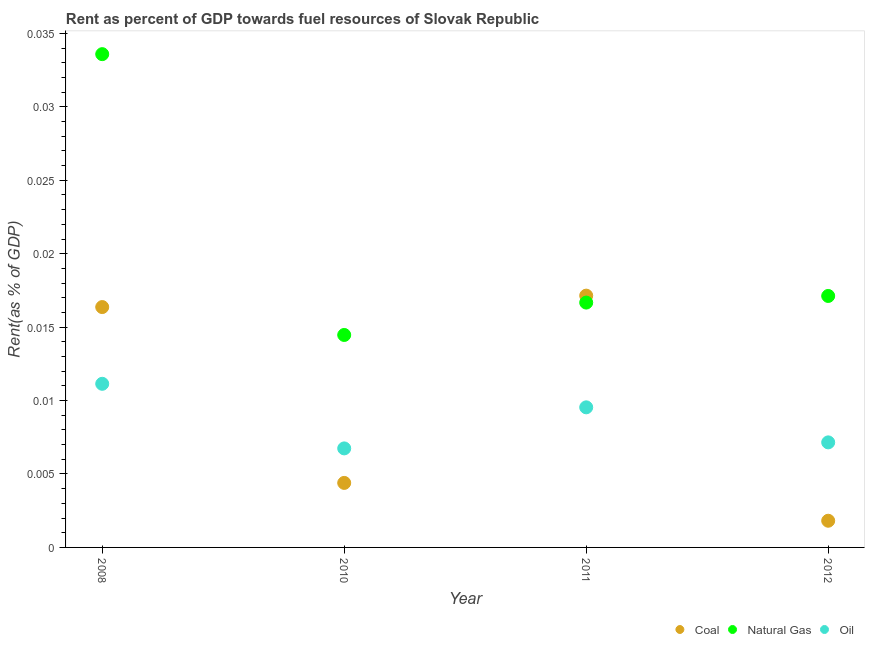How many different coloured dotlines are there?
Offer a very short reply. 3. What is the rent towards natural gas in 2012?
Your response must be concise. 0.02. Across all years, what is the maximum rent towards coal?
Give a very brief answer. 0.02. Across all years, what is the minimum rent towards oil?
Your answer should be compact. 0.01. In which year was the rent towards oil minimum?
Provide a succinct answer. 2010. What is the total rent towards oil in the graph?
Make the answer very short. 0.03. What is the difference between the rent towards coal in 2008 and that in 2010?
Give a very brief answer. 0.01. What is the difference between the rent towards oil in 2011 and the rent towards natural gas in 2010?
Give a very brief answer. -0. What is the average rent towards oil per year?
Make the answer very short. 0.01. In the year 2012, what is the difference between the rent towards coal and rent towards natural gas?
Give a very brief answer. -0.02. In how many years, is the rent towards oil greater than 0.007 %?
Make the answer very short. 3. What is the ratio of the rent towards coal in 2008 to that in 2012?
Offer a very short reply. 9.01. Is the rent towards coal in 2008 less than that in 2010?
Provide a succinct answer. No. What is the difference between the highest and the second highest rent towards coal?
Keep it short and to the point. 0. What is the difference between the highest and the lowest rent towards oil?
Provide a short and direct response. 0. In how many years, is the rent towards coal greater than the average rent towards coal taken over all years?
Your response must be concise. 2. Is the sum of the rent towards oil in 2008 and 2010 greater than the maximum rent towards coal across all years?
Provide a succinct answer. Yes. Is it the case that in every year, the sum of the rent towards coal and rent towards natural gas is greater than the rent towards oil?
Your response must be concise. Yes. Does the rent towards coal monotonically increase over the years?
Ensure brevity in your answer.  No. Is the rent towards natural gas strictly less than the rent towards coal over the years?
Your answer should be very brief. No. How many dotlines are there?
Your answer should be very brief. 3. How many years are there in the graph?
Provide a short and direct response. 4. What is the difference between two consecutive major ticks on the Y-axis?
Your answer should be compact. 0.01. Are the values on the major ticks of Y-axis written in scientific E-notation?
Your response must be concise. No. How are the legend labels stacked?
Your answer should be compact. Horizontal. What is the title of the graph?
Your answer should be very brief. Rent as percent of GDP towards fuel resources of Slovak Republic. What is the label or title of the Y-axis?
Make the answer very short. Rent(as % of GDP). What is the Rent(as % of GDP) in Coal in 2008?
Keep it short and to the point. 0.02. What is the Rent(as % of GDP) in Natural Gas in 2008?
Provide a succinct answer. 0.03. What is the Rent(as % of GDP) in Oil in 2008?
Make the answer very short. 0.01. What is the Rent(as % of GDP) in Coal in 2010?
Offer a terse response. 0. What is the Rent(as % of GDP) in Natural Gas in 2010?
Provide a succinct answer. 0.01. What is the Rent(as % of GDP) of Oil in 2010?
Provide a short and direct response. 0.01. What is the Rent(as % of GDP) of Coal in 2011?
Provide a short and direct response. 0.02. What is the Rent(as % of GDP) of Natural Gas in 2011?
Your response must be concise. 0.02. What is the Rent(as % of GDP) in Oil in 2011?
Your response must be concise. 0.01. What is the Rent(as % of GDP) in Coal in 2012?
Your answer should be very brief. 0. What is the Rent(as % of GDP) of Natural Gas in 2012?
Provide a succinct answer. 0.02. What is the Rent(as % of GDP) in Oil in 2012?
Ensure brevity in your answer.  0.01. Across all years, what is the maximum Rent(as % of GDP) in Coal?
Keep it short and to the point. 0.02. Across all years, what is the maximum Rent(as % of GDP) of Natural Gas?
Provide a short and direct response. 0.03. Across all years, what is the maximum Rent(as % of GDP) in Oil?
Give a very brief answer. 0.01. Across all years, what is the minimum Rent(as % of GDP) in Coal?
Your answer should be very brief. 0. Across all years, what is the minimum Rent(as % of GDP) in Natural Gas?
Keep it short and to the point. 0.01. Across all years, what is the minimum Rent(as % of GDP) of Oil?
Offer a terse response. 0.01. What is the total Rent(as % of GDP) in Coal in the graph?
Provide a succinct answer. 0.04. What is the total Rent(as % of GDP) in Natural Gas in the graph?
Keep it short and to the point. 0.08. What is the total Rent(as % of GDP) of Oil in the graph?
Keep it short and to the point. 0.03. What is the difference between the Rent(as % of GDP) of Coal in 2008 and that in 2010?
Offer a very short reply. 0.01. What is the difference between the Rent(as % of GDP) in Natural Gas in 2008 and that in 2010?
Provide a succinct answer. 0.02. What is the difference between the Rent(as % of GDP) of Oil in 2008 and that in 2010?
Provide a succinct answer. 0. What is the difference between the Rent(as % of GDP) in Coal in 2008 and that in 2011?
Your response must be concise. -0. What is the difference between the Rent(as % of GDP) in Natural Gas in 2008 and that in 2011?
Offer a terse response. 0.02. What is the difference between the Rent(as % of GDP) of Oil in 2008 and that in 2011?
Provide a short and direct response. 0. What is the difference between the Rent(as % of GDP) of Coal in 2008 and that in 2012?
Provide a short and direct response. 0.01. What is the difference between the Rent(as % of GDP) of Natural Gas in 2008 and that in 2012?
Keep it short and to the point. 0.02. What is the difference between the Rent(as % of GDP) in Oil in 2008 and that in 2012?
Your response must be concise. 0. What is the difference between the Rent(as % of GDP) in Coal in 2010 and that in 2011?
Offer a terse response. -0.01. What is the difference between the Rent(as % of GDP) in Natural Gas in 2010 and that in 2011?
Offer a very short reply. -0. What is the difference between the Rent(as % of GDP) in Oil in 2010 and that in 2011?
Provide a succinct answer. -0. What is the difference between the Rent(as % of GDP) of Coal in 2010 and that in 2012?
Provide a short and direct response. 0. What is the difference between the Rent(as % of GDP) in Natural Gas in 2010 and that in 2012?
Your answer should be compact. -0. What is the difference between the Rent(as % of GDP) in Oil in 2010 and that in 2012?
Offer a terse response. -0. What is the difference between the Rent(as % of GDP) of Coal in 2011 and that in 2012?
Your answer should be compact. 0.02. What is the difference between the Rent(as % of GDP) in Natural Gas in 2011 and that in 2012?
Provide a succinct answer. -0. What is the difference between the Rent(as % of GDP) of Oil in 2011 and that in 2012?
Give a very brief answer. 0. What is the difference between the Rent(as % of GDP) in Coal in 2008 and the Rent(as % of GDP) in Natural Gas in 2010?
Provide a succinct answer. 0. What is the difference between the Rent(as % of GDP) in Coal in 2008 and the Rent(as % of GDP) in Oil in 2010?
Give a very brief answer. 0.01. What is the difference between the Rent(as % of GDP) of Natural Gas in 2008 and the Rent(as % of GDP) of Oil in 2010?
Your response must be concise. 0.03. What is the difference between the Rent(as % of GDP) of Coal in 2008 and the Rent(as % of GDP) of Natural Gas in 2011?
Your response must be concise. -0. What is the difference between the Rent(as % of GDP) of Coal in 2008 and the Rent(as % of GDP) of Oil in 2011?
Keep it short and to the point. 0.01. What is the difference between the Rent(as % of GDP) in Natural Gas in 2008 and the Rent(as % of GDP) in Oil in 2011?
Your response must be concise. 0.02. What is the difference between the Rent(as % of GDP) in Coal in 2008 and the Rent(as % of GDP) in Natural Gas in 2012?
Keep it short and to the point. -0. What is the difference between the Rent(as % of GDP) of Coal in 2008 and the Rent(as % of GDP) of Oil in 2012?
Provide a succinct answer. 0.01. What is the difference between the Rent(as % of GDP) in Natural Gas in 2008 and the Rent(as % of GDP) in Oil in 2012?
Your answer should be very brief. 0.03. What is the difference between the Rent(as % of GDP) of Coal in 2010 and the Rent(as % of GDP) of Natural Gas in 2011?
Offer a terse response. -0.01. What is the difference between the Rent(as % of GDP) in Coal in 2010 and the Rent(as % of GDP) in Oil in 2011?
Your answer should be compact. -0.01. What is the difference between the Rent(as % of GDP) of Natural Gas in 2010 and the Rent(as % of GDP) of Oil in 2011?
Your answer should be very brief. 0. What is the difference between the Rent(as % of GDP) in Coal in 2010 and the Rent(as % of GDP) in Natural Gas in 2012?
Keep it short and to the point. -0.01. What is the difference between the Rent(as % of GDP) of Coal in 2010 and the Rent(as % of GDP) of Oil in 2012?
Make the answer very short. -0. What is the difference between the Rent(as % of GDP) of Natural Gas in 2010 and the Rent(as % of GDP) of Oil in 2012?
Provide a short and direct response. 0.01. What is the difference between the Rent(as % of GDP) of Coal in 2011 and the Rent(as % of GDP) of Natural Gas in 2012?
Give a very brief answer. 0. What is the difference between the Rent(as % of GDP) in Coal in 2011 and the Rent(as % of GDP) in Oil in 2012?
Make the answer very short. 0.01. What is the difference between the Rent(as % of GDP) of Natural Gas in 2011 and the Rent(as % of GDP) of Oil in 2012?
Keep it short and to the point. 0.01. What is the average Rent(as % of GDP) of Coal per year?
Provide a succinct answer. 0.01. What is the average Rent(as % of GDP) in Natural Gas per year?
Offer a terse response. 0.02. What is the average Rent(as % of GDP) of Oil per year?
Your answer should be very brief. 0.01. In the year 2008, what is the difference between the Rent(as % of GDP) in Coal and Rent(as % of GDP) in Natural Gas?
Provide a short and direct response. -0.02. In the year 2008, what is the difference between the Rent(as % of GDP) of Coal and Rent(as % of GDP) of Oil?
Your answer should be very brief. 0.01. In the year 2008, what is the difference between the Rent(as % of GDP) of Natural Gas and Rent(as % of GDP) of Oil?
Make the answer very short. 0.02. In the year 2010, what is the difference between the Rent(as % of GDP) in Coal and Rent(as % of GDP) in Natural Gas?
Offer a terse response. -0.01. In the year 2010, what is the difference between the Rent(as % of GDP) in Coal and Rent(as % of GDP) in Oil?
Your answer should be compact. -0. In the year 2010, what is the difference between the Rent(as % of GDP) in Natural Gas and Rent(as % of GDP) in Oil?
Provide a succinct answer. 0.01. In the year 2011, what is the difference between the Rent(as % of GDP) of Coal and Rent(as % of GDP) of Oil?
Give a very brief answer. 0.01. In the year 2011, what is the difference between the Rent(as % of GDP) in Natural Gas and Rent(as % of GDP) in Oil?
Keep it short and to the point. 0.01. In the year 2012, what is the difference between the Rent(as % of GDP) in Coal and Rent(as % of GDP) in Natural Gas?
Keep it short and to the point. -0.02. In the year 2012, what is the difference between the Rent(as % of GDP) of Coal and Rent(as % of GDP) of Oil?
Ensure brevity in your answer.  -0.01. In the year 2012, what is the difference between the Rent(as % of GDP) of Natural Gas and Rent(as % of GDP) of Oil?
Provide a succinct answer. 0.01. What is the ratio of the Rent(as % of GDP) of Coal in 2008 to that in 2010?
Give a very brief answer. 3.73. What is the ratio of the Rent(as % of GDP) in Natural Gas in 2008 to that in 2010?
Your answer should be compact. 2.32. What is the ratio of the Rent(as % of GDP) in Oil in 2008 to that in 2010?
Your response must be concise. 1.65. What is the ratio of the Rent(as % of GDP) of Coal in 2008 to that in 2011?
Your answer should be very brief. 0.95. What is the ratio of the Rent(as % of GDP) of Natural Gas in 2008 to that in 2011?
Your answer should be very brief. 2.01. What is the ratio of the Rent(as % of GDP) of Oil in 2008 to that in 2011?
Your response must be concise. 1.17. What is the ratio of the Rent(as % of GDP) of Coal in 2008 to that in 2012?
Offer a very short reply. 9.01. What is the ratio of the Rent(as % of GDP) in Natural Gas in 2008 to that in 2012?
Your response must be concise. 1.96. What is the ratio of the Rent(as % of GDP) of Oil in 2008 to that in 2012?
Provide a succinct answer. 1.56. What is the ratio of the Rent(as % of GDP) in Coal in 2010 to that in 2011?
Your response must be concise. 0.26. What is the ratio of the Rent(as % of GDP) in Natural Gas in 2010 to that in 2011?
Provide a short and direct response. 0.87. What is the ratio of the Rent(as % of GDP) of Oil in 2010 to that in 2011?
Your response must be concise. 0.71. What is the ratio of the Rent(as % of GDP) of Coal in 2010 to that in 2012?
Your answer should be very brief. 2.42. What is the ratio of the Rent(as % of GDP) in Natural Gas in 2010 to that in 2012?
Your answer should be very brief. 0.84. What is the ratio of the Rent(as % of GDP) of Oil in 2010 to that in 2012?
Keep it short and to the point. 0.94. What is the ratio of the Rent(as % of GDP) of Coal in 2011 to that in 2012?
Offer a terse response. 9.44. What is the ratio of the Rent(as % of GDP) in Natural Gas in 2011 to that in 2012?
Your response must be concise. 0.97. What is the ratio of the Rent(as % of GDP) in Oil in 2011 to that in 2012?
Your response must be concise. 1.33. What is the difference between the highest and the second highest Rent(as % of GDP) in Coal?
Your answer should be compact. 0. What is the difference between the highest and the second highest Rent(as % of GDP) of Natural Gas?
Make the answer very short. 0.02. What is the difference between the highest and the second highest Rent(as % of GDP) in Oil?
Give a very brief answer. 0. What is the difference between the highest and the lowest Rent(as % of GDP) in Coal?
Make the answer very short. 0.02. What is the difference between the highest and the lowest Rent(as % of GDP) in Natural Gas?
Provide a succinct answer. 0.02. What is the difference between the highest and the lowest Rent(as % of GDP) of Oil?
Your response must be concise. 0. 